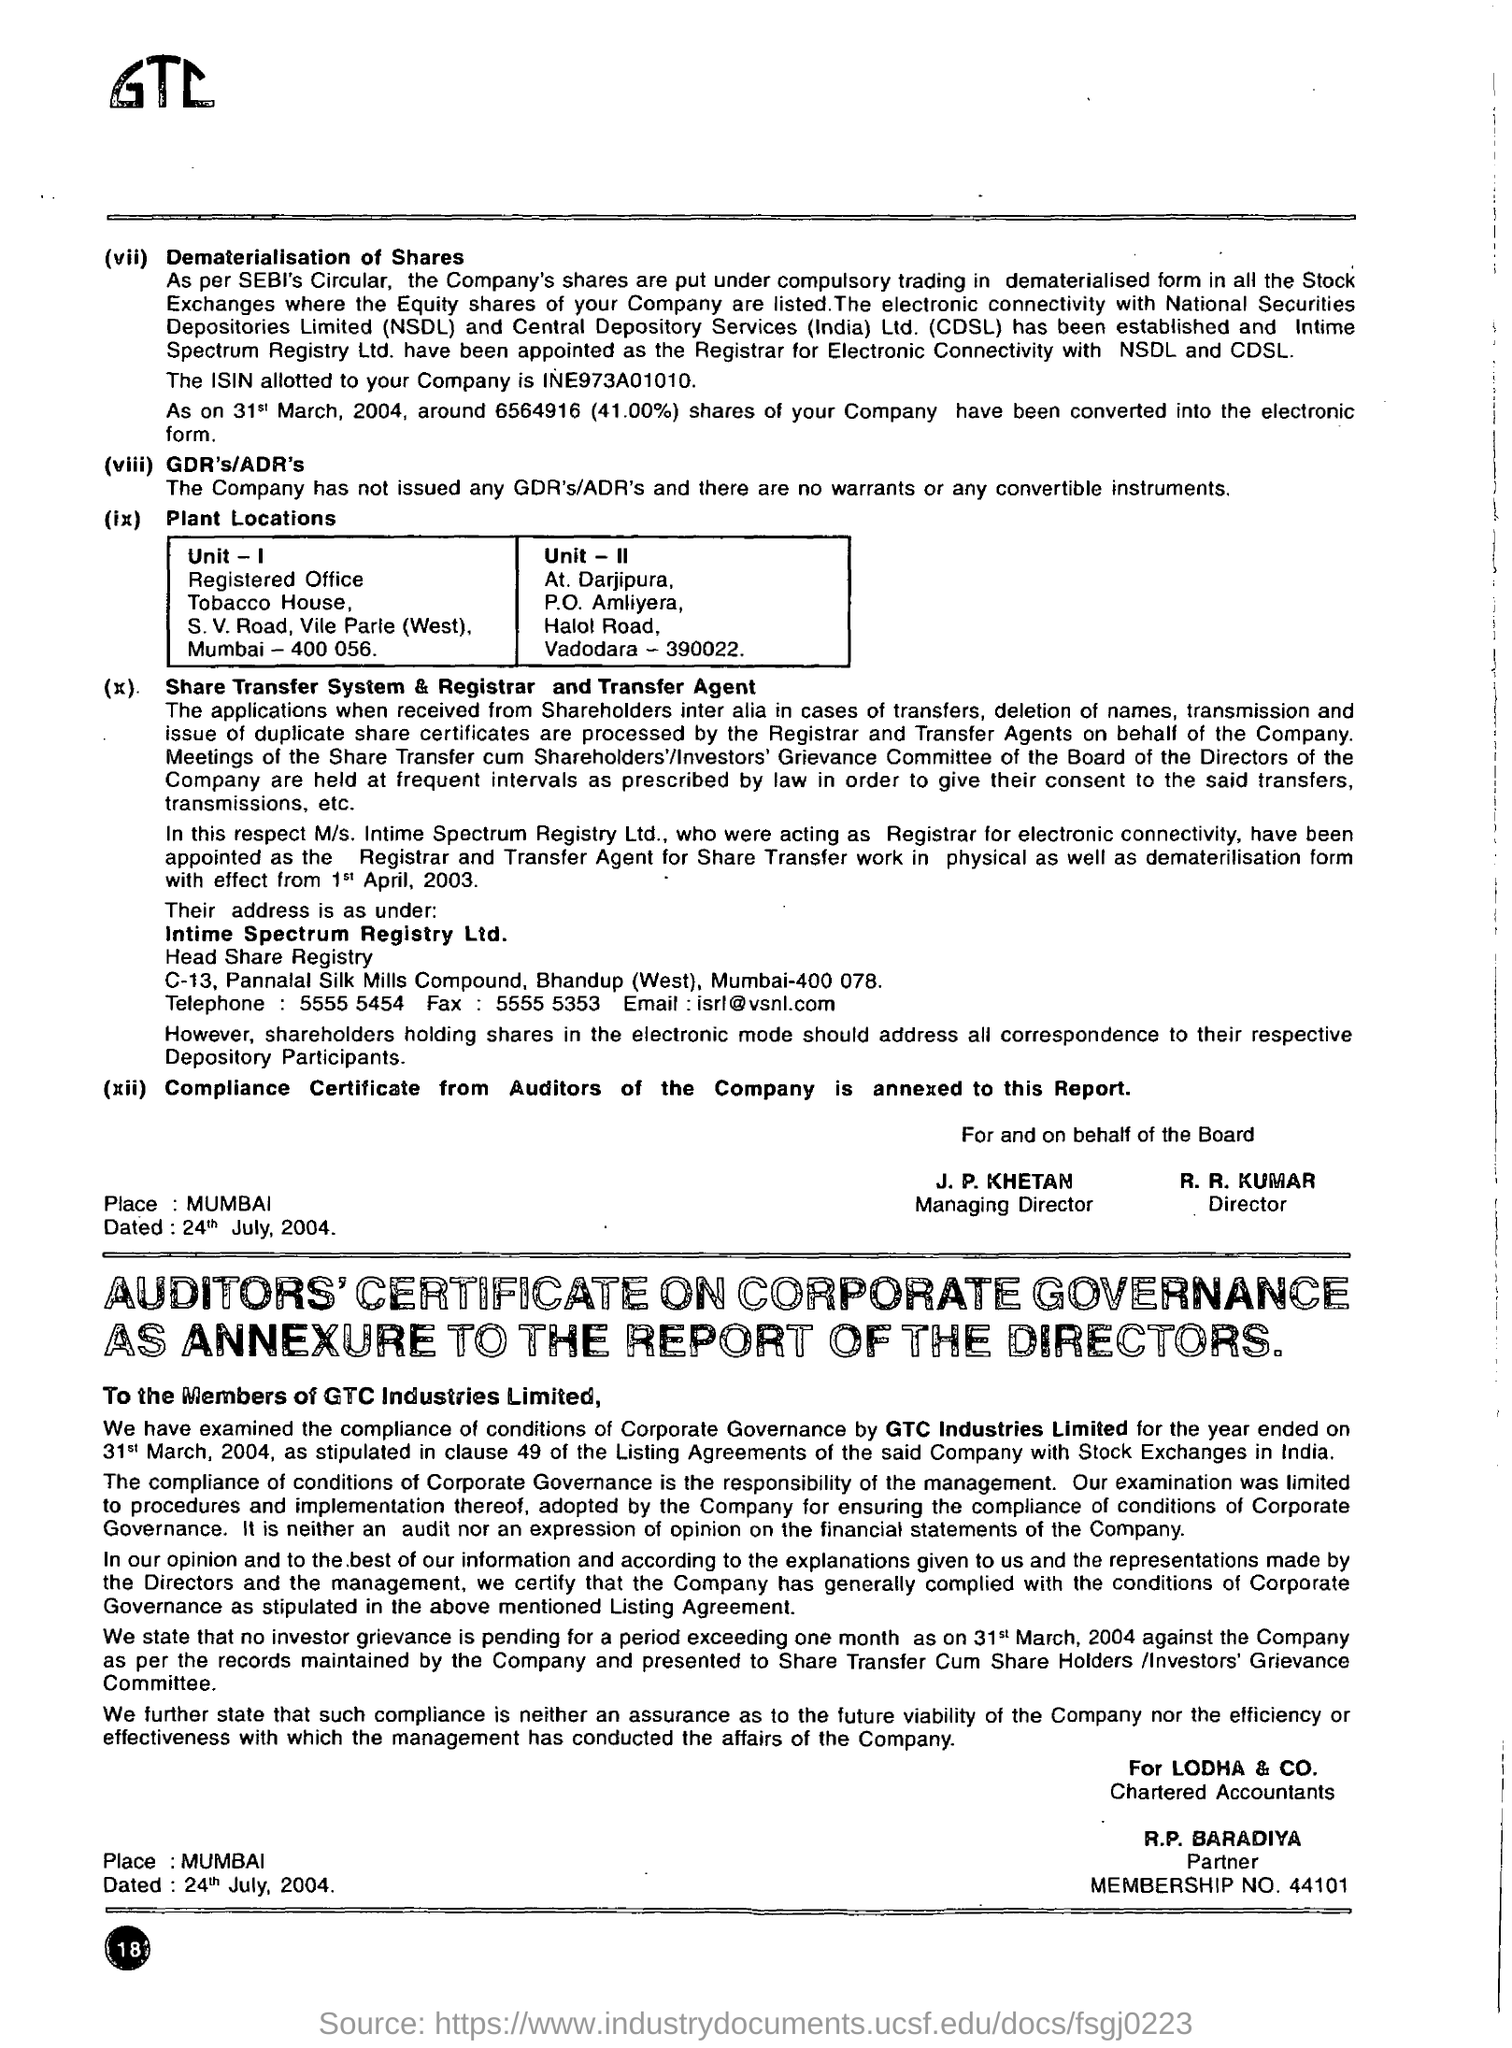what is the name of the company?
 gtc industries limited 